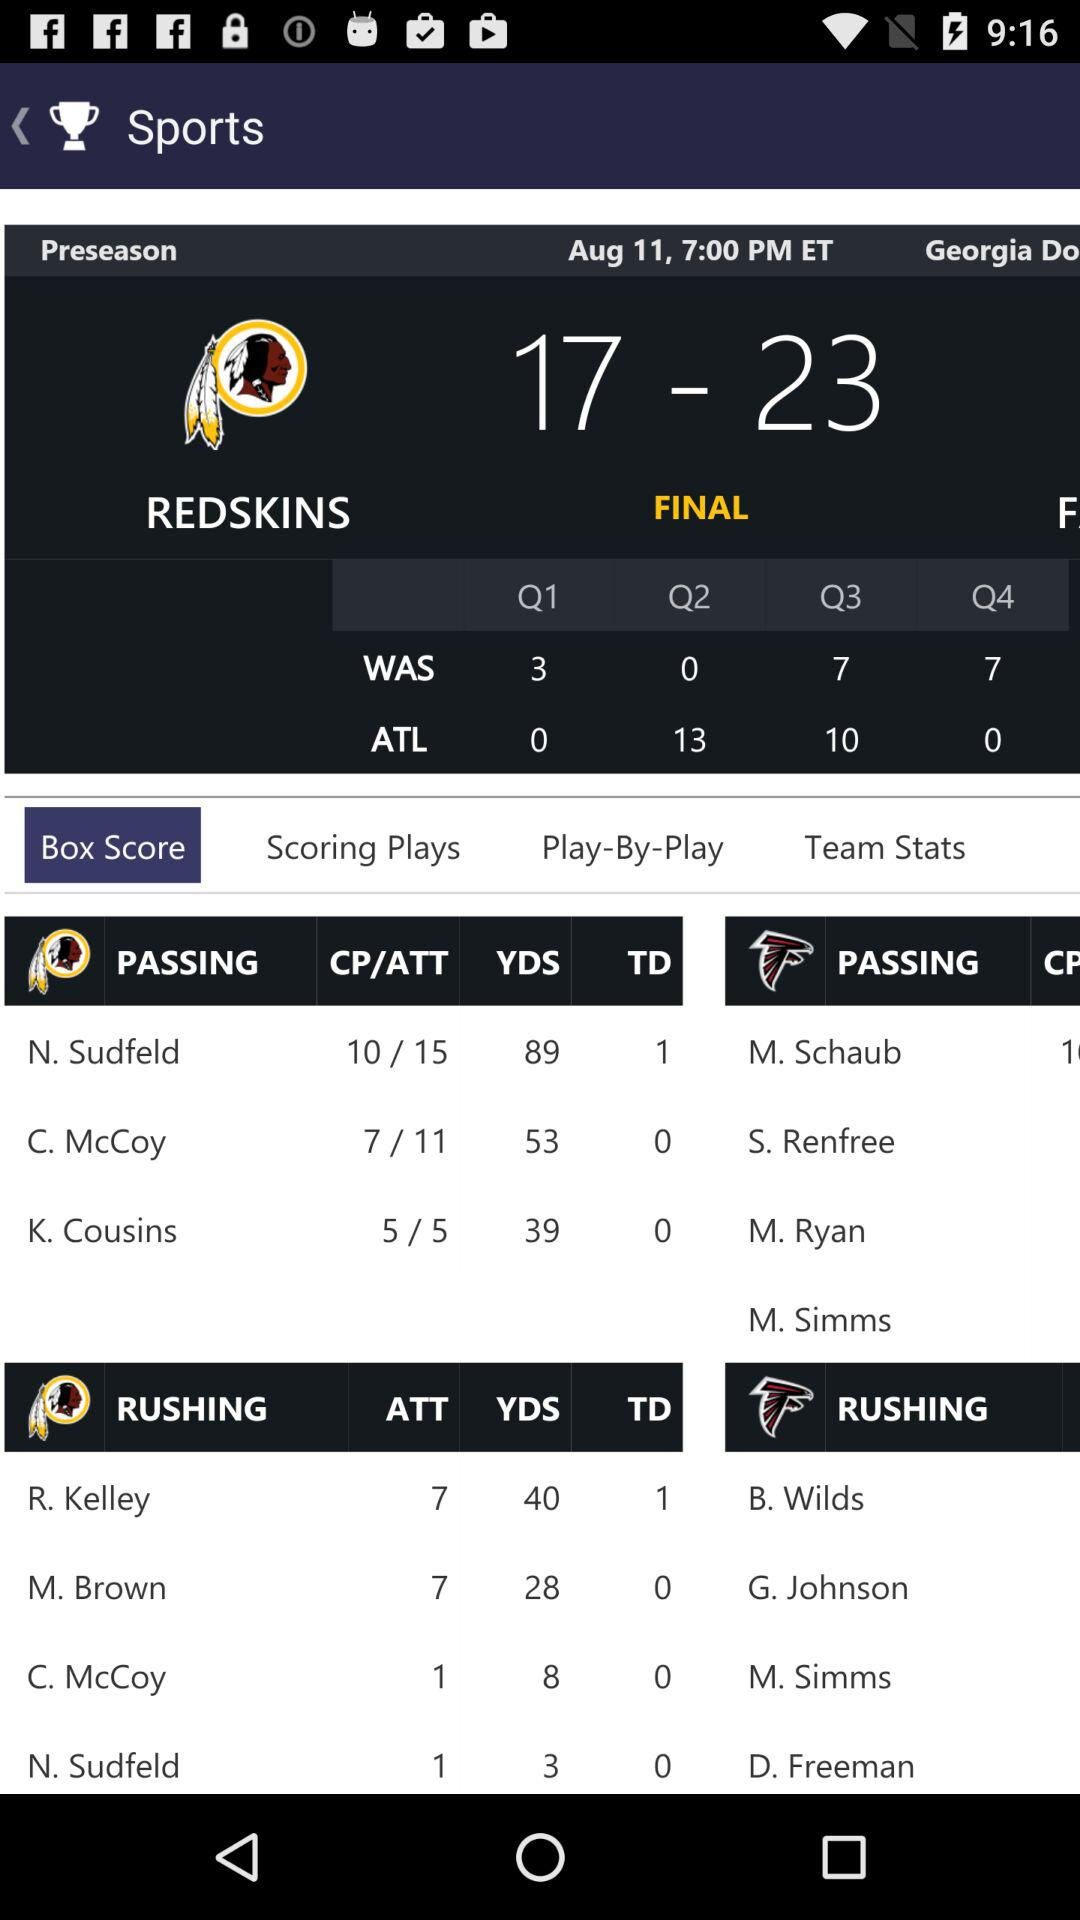What is the number of passing yards for C. McCoy? The number of passing yards for C. McCoy is 53. 